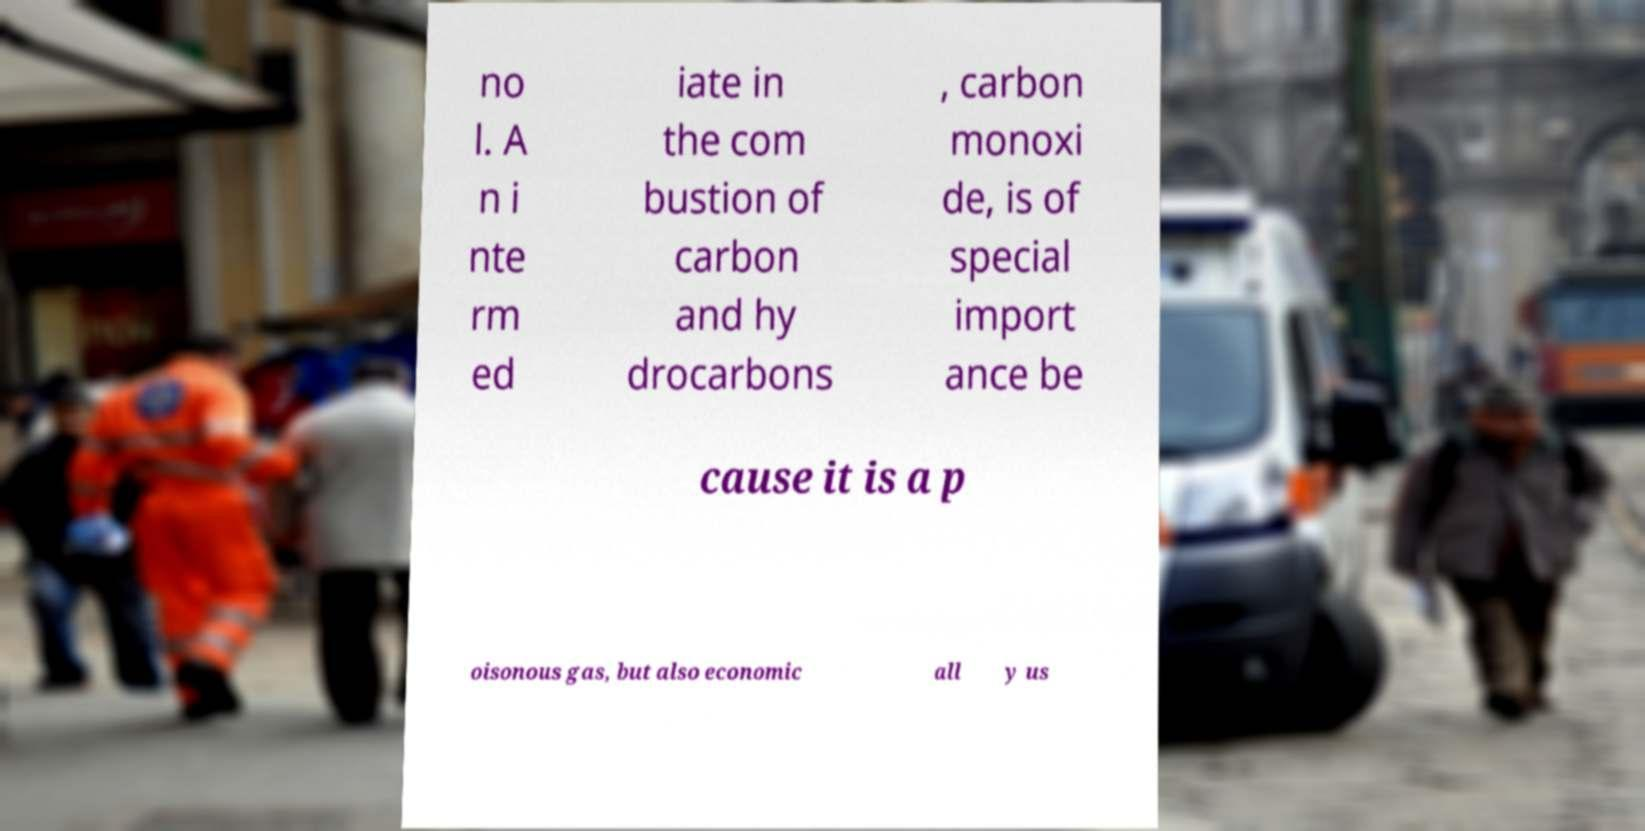Could you assist in decoding the text presented in this image and type it out clearly? no l. A n i nte rm ed iate in the com bustion of carbon and hy drocarbons , carbon monoxi de, is of special import ance be cause it is a p oisonous gas, but also economic all y us 